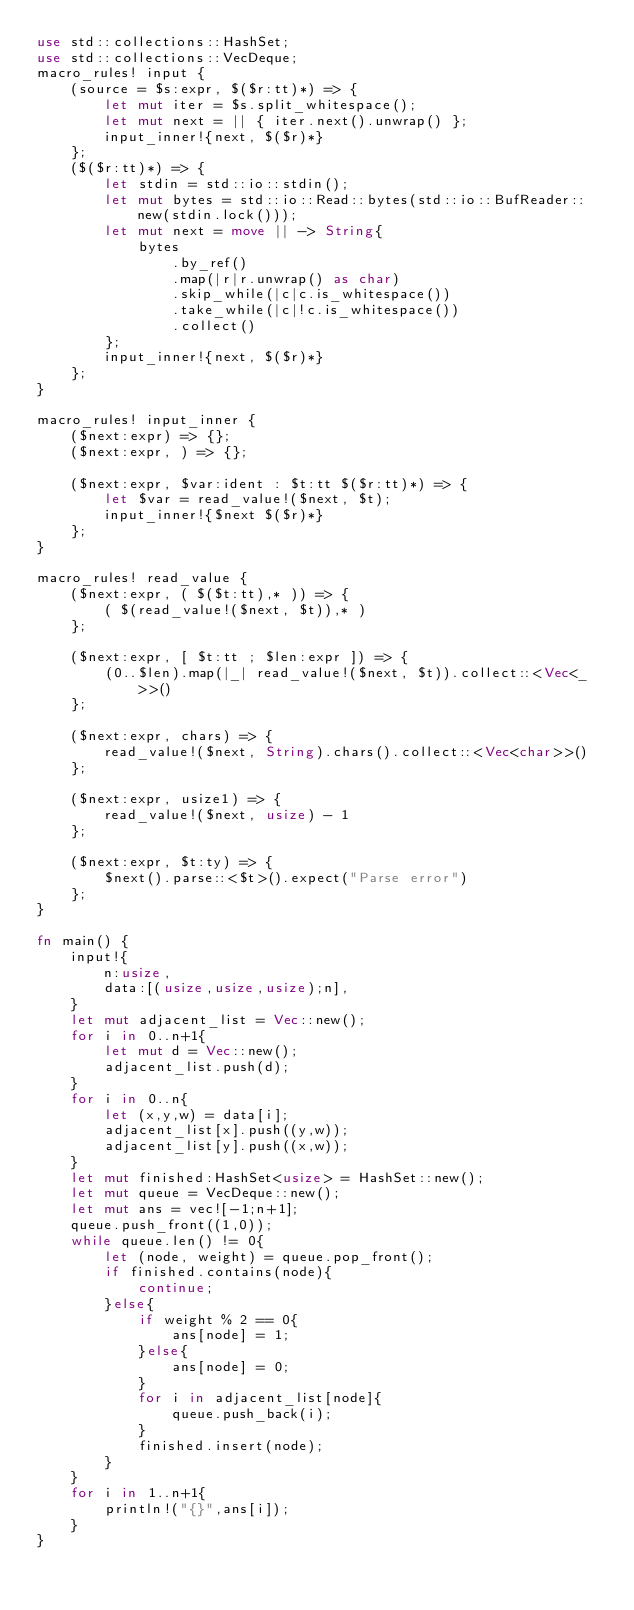Convert code to text. <code><loc_0><loc_0><loc_500><loc_500><_Rust_>use std::collections::HashSet;
use std::collections::VecDeque;
macro_rules! input {
    (source = $s:expr, $($r:tt)*) => {
        let mut iter = $s.split_whitespace();
        let mut next = || { iter.next().unwrap() };
        input_inner!{next, $($r)*}
    };
    ($($r:tt)*) => {
        let stdin = std::io::stdin();
        let mut bytes = std::io::Read::bytes(std::io::BufReader::new(stdin.lock()));
        let mut next = move || -> String{
            bytes
                .by_ref()
                .map(|r|r.unwrap() as char)
                .skip_while(|c|c.is_whitespace())
                .take_while(|c|!c.is_whitespace())
                .collect()
        };
        input_inner!{next, $($r)*}
    };
}

macro_rules! input_inner {
    ($next:expr) => {};
    ($next:expr, ) => {};

    ($next:expr, $var:ident : $t:tt $($r:tt)*) => {
        let $var = read_value!($next, $t);
        input_inner!{$next $($r)*}
    };
}

macro_rules! read_value {
    ($next:expr, ( $($t:tt),* )) => {
        ( $(read_value!($next, $t)),* )
    };

    ($next:expr, [ $t:tt ; $len:expr ]) => {
        (0..$len).map(|_| read_value!($next, $t)).collect::<Vec<_>>()
    };

    ($next:expr, chars) => {
        read_value!($next, String).chars().collect::<Vec<char>>()
    };

    ($next:expr, usize1) => {
        read_value!($next, usize) - 1
    };

    ($next:expr, $t:ty) => {
        $next().parse::<$t>().expect("Parse error")
    };
}

fn main() {
    input!{
        n:usize,
        data:[(usize,usize,usize);n],
    }
    let mut adjacent_list = Vec::new();
    for i in 0..n+1{
        let mut d = Vec::new();
        adjacent_list.push(d);
    }
    for i in 0..n{
        let (x,y,w) = data[i];
        adjacent_list[x].push((y,w));
        adjacent_list[y].push((x,w));
    }
    let mut finished:HashSet<usize> = HashSet::new();
    let mut queue = VecDeque::new();
    let mut ans = vec![-1;n+1];
    queue.push_front((1,0));
    while queue.len() != 0{
        let (node, weight) = queue.pop_front();
        if finished.contains(node){
            continue;
        }else{
            if weight % 2 == 0{
                ans[node] = 1;
            }else{
                ans[node] = 0;
            }
            for i in adjacent_list[node]{
                queue.push_back(i);
            }
            finished.insert(node);
        }
    }
    for i in 1..n+1{
        println!("{}",ans[i]);
    }
}</code> 